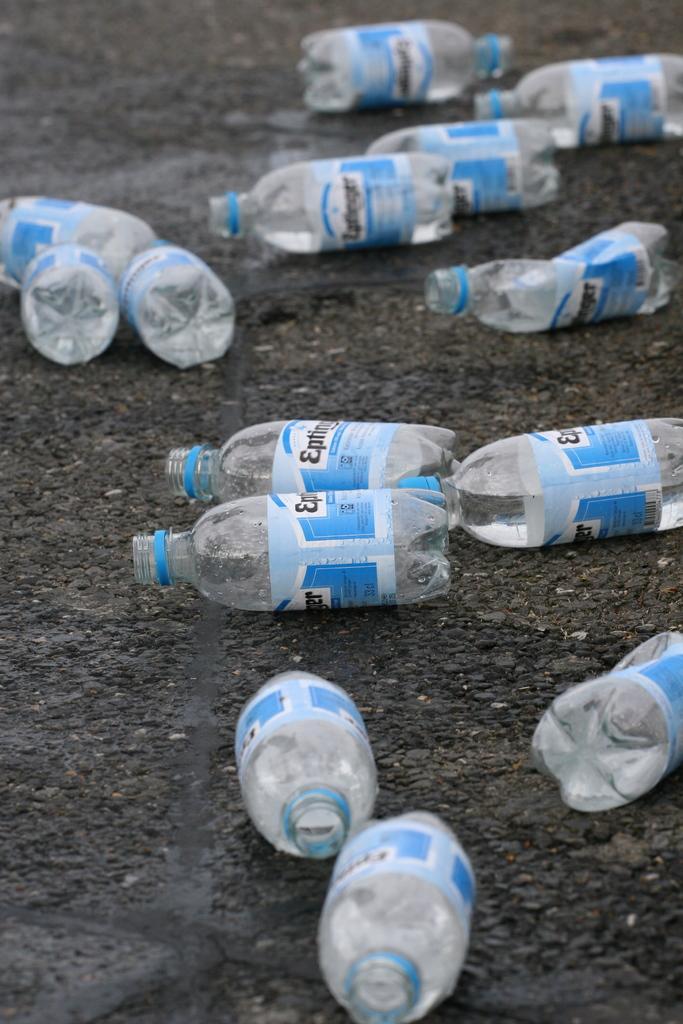Describe this image in one or two sentences. This image is taken in outdoors. In this image there is a road and there were many empty bottles thrown on a road. 